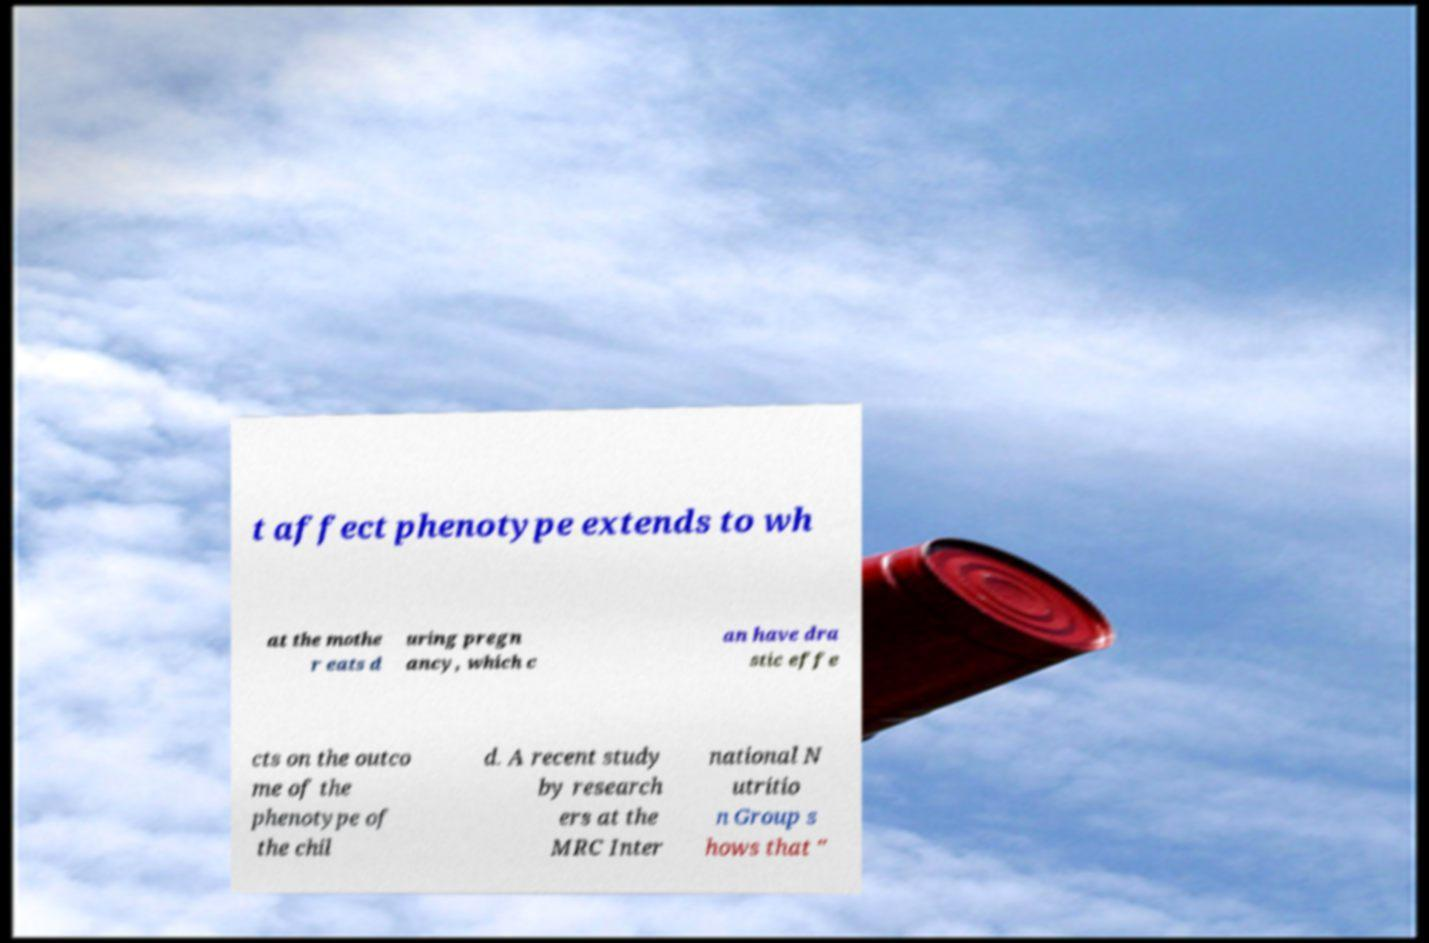For documentation purposes, I need the text within this image transcribed. Could you provide that? t affect phenotype extends to wh at the mothe r eats d uring pregn ancy, which c an have dra stic effe cts on the outco me of the phenotype of the chil d. A recent study by research ers at the MRC Inter national N utritio n Group s hows that " 